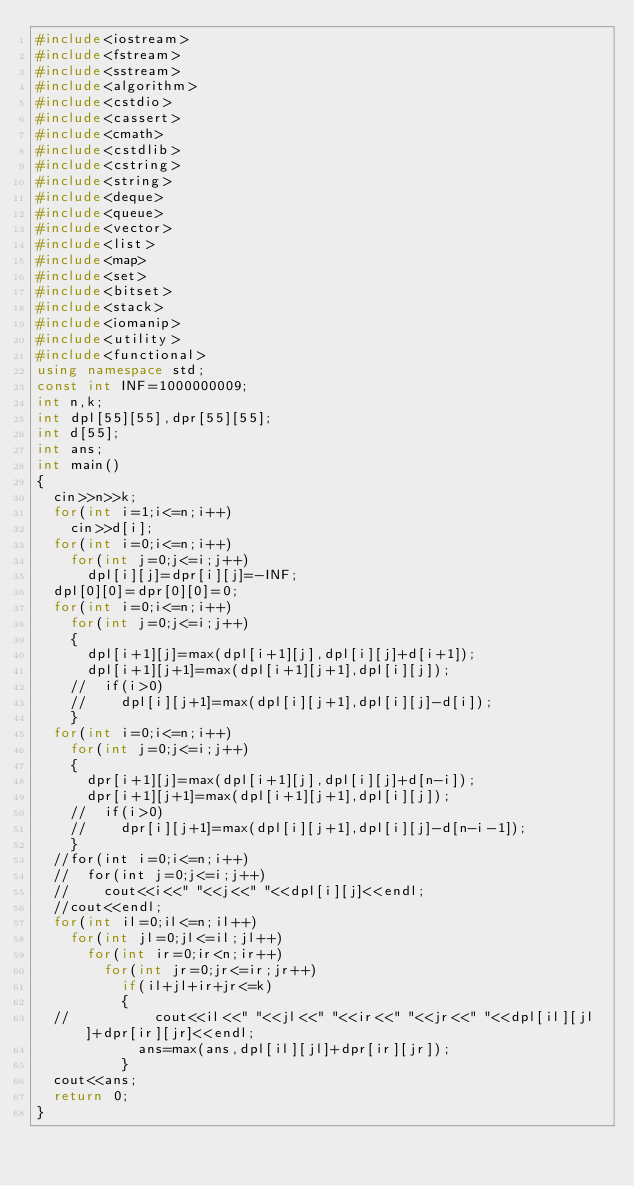Convert code to text. <code><loc_0><loc_0><loc_500><loc_500><_C++_>#include<iostream>
#include<fstream>
#include<sstream>
#include<algorithm>
#include<cstdio>
#include<cassert>
#include<cmath>
#include<cstdlib>
#include<cstring>
#include<string>
#include<deque>
#include<queue>
#include<vector>
#include<list>
#include<map>
#include<set>
#include<bitset>
#include<stack>
#include<iomanip>
#include<utility>
#include<functional>
using namespace std;
const int INF=1000000009;
int n,k;
int dpl[55][55],dpr[55][55];
int d[55];
int ans;
int main()
{
	cin>>n>>k;
	for(int i=1;i<=n;i++)
		cin>>d[i];
	for(int i=0;i<=n;i++)
		for(int j=0;j<=i;j++)
			dpl[i][j]=dpr[i][j]=-INF;
	dpl[0][0]=dpr[0][0]=0;
	for(int i=0;i<=n;i++)
		for(int j=0;j<=i;j++)
		{
			dpl[i+1][j]=max(dpl[i+1][j],dpl[i][j]+d[i+1]);
			dpl[i+1][j+1]=max(dpl[i+1][j+1],dpl[i][j]);
		//	if(i>0)
		//		dpl[i][j+1]=max(dpl[i][j+1],dpl[i][j]-d[i]);
		}
	for(int i=0;i<=n;i++)
		for(int j=0;j<=i;j++)
		{
			dpr[i+1][j]=max(dpl[i+1][j],dpl[i][j]+d[n-i]);
			dpr[i+1][j+1]=max(dpl[i+1][j+1],dpl[i][j]);
		//	if(i>0)
		//		dpr[i][j+1]=max(dpl[i][j+1],dpl[i][j]-d[n-i-1]);
		}
	//for(int i=0;i<=n;i++)
	//	for(int j=0;j<=i;j++)
	//		cout<<i<<" "<<j<<" "<<dpl[i][j]<<endl;
	//cout<<endl;
	for(int il=0;il<=n;il++)
		for(int jl=0;jl<=il;jl++)
			for(int ir=0;ir<n;ir++)
				for(int jr=0;jr<=ir;jr++)
					if(il+jl+ir+jr<=k)
					{	
	//					cout<<il<<" "<<jl<<" "<<ir<<" "<<jr<<" "<<dpl[il][jl]+dpr[ir][jr]<<endl;
						ans=max(ans,dpl[il][jl]+dpr[ir][jr]);
					}
	cout<<ans;
	return 0;
}
</code> 